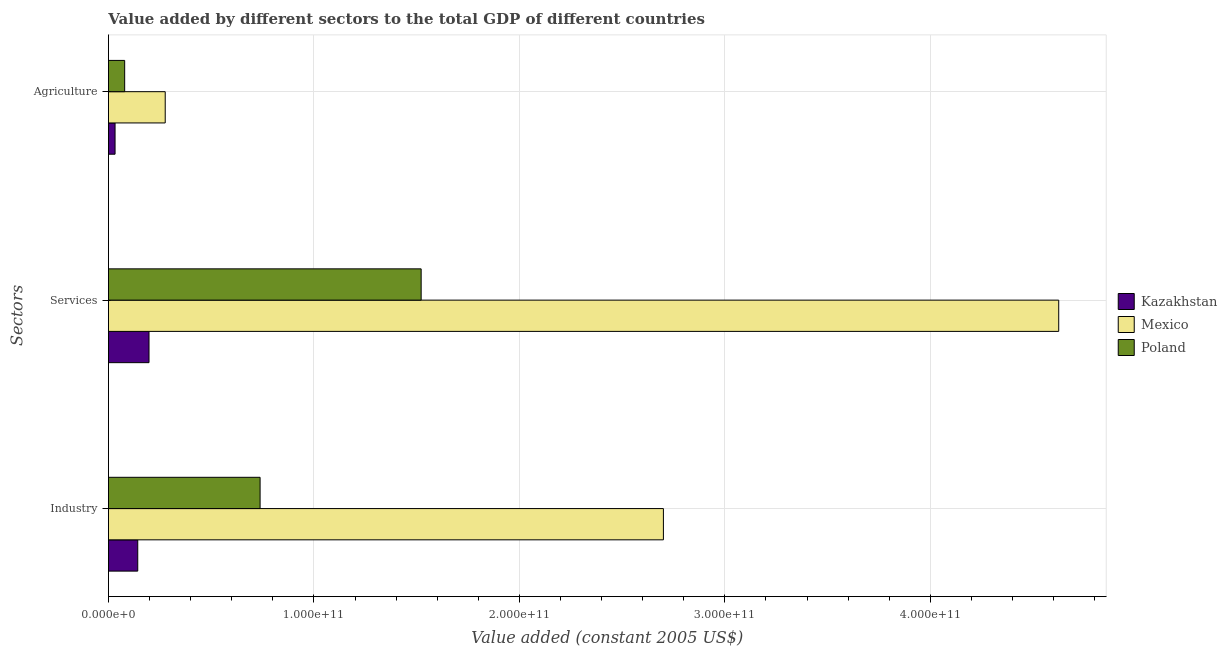How many groups of bars are there?
Offer a very short reply. 3. Are the number of bars per tick equal to the number of legend labels?
Make the answer very short. Yes. How many bars are there on the 3rd tick from the top?
Your answer should be very brief. 3. How many bars are there on the 3rd tick from the bottom?
Provide a short and direct response. 3. What is the label of the 3rd group of bars from the top?
Provide a succinct answer. Industry. What is the value added by agricultural sector in Mexico?
Offer a very short reply. 2.76e+1. Across all countries, what is the maximum value added by services?
Ensure brevity in your answer.  4.62e+11. Across all countries, what is the minimum value added by services?
Provide a succinct answer. 1.97e+1. In which country was the value added by agricultural sector minimum?
Offer a very short reply. Kazakhstan. What is the total value added by agricultural sector in the graph?
Offer a very short reply. 3.88e+1. What is the difference between the value added by services in Mexico and that in Kazakhstan?
Provide a short and direct response. 4.43e+11. What is the difference between the value added by agricultural sector in Kazakhstan and the value added by services in Mexico?
Your answer should be compact. -4.59e+11. What is the average value added by services per country?
Provide a short and direct response. 2.11e+11. What is the difference between the value added by industrial sector and value added by services in Mexico?
Provide a succinct answer. -1.92e+11. In how many countries, is the value added by industrial sector greater than 140000000000 US$?
Your answer should be compact. 1. What is the ratio of the value added by agricultural sector in Kazakhstan to that in Mexico?
Your answer should be compact. 0.12. Is the value added by industrial sector in Mexico less than that in Kazakhstan?
Offer a terse response. No. What is the difference between the highest and the second highest value added by agricultural sector?
Keep it short and to the point. 1.97e+1. What is the difference between the highest and the lowest value added by agricultural sector?
Ensure brevity in your answer.  2.44e+1. What does the 3rd bar from the top in Industry represents?
Ensure brevity in your answer.  Kazakhstan. Is it the case that in every country, the sum of the value added by industrial sector and value added by services is greater than the value added by agricultural sector?
Give a very brief answer. Yes. How many bars are there?
Give a very brief answer. 9. Are all the bars in the graph horizontal?
Make the answer very short. Yes. How many countries are there in the graph?
Your answer should be very brief. 3. What is the difference between two consecutive major ticks on the X-axis?
Provide a short and direct response. 1.00e+11. Does the graph contain any zero values?
Offer a terse response. No. Where does the legend appear in the graph?
Make the answer very short. Center right. What is the title of the graph?
Your answer should be compact. Value added by different sectors to the total GDP of different countries. Does "Vanuatu" appear as one of the legend labels in the graph?
Your answer should be very brief. No. What is the label or title of the X-axis?
Provide a succinct answer. Value added (constant 2005 US$). What is the label or title of the Y-axis?
Offer a terse response. Sectors. What is the Value added (constant 2005 US$) of Kazakhstan in Industry?
Keep it short and to the point. 1.43e+1. What is the Value added (constant 2005 US$) in Mexico in Industry?
Keep it short and to the point. 2.70e+11. What is the Value added (constant 2005 US$) of Poland in Industry?
Offer a terse response. 7.38e+1. What is the Value added (constant 2005 US$) in Kazakhstan in Services?
Provide a short and direct response. 1.97e+1. What is the Value added (constant 2005 US$) of Mexico in Services?
Provide a short and direct response. 4.62e+11. What is the Value added (constant 2005 US$) in Poland in Services?
Your answer should be compact. 1.52e+11. What is the Value added (constant 2005 US$) in Kazakhstan in Agriculture?
Offer a very short reply. 3.22e+09. What is the Value added (constant 2005 US$) in Mexico in Agriculture?
Offer a very short reply. 2.76e+1. What is the Value added (constant 2005 US$) of Poland in Agriculture?
Provide a short and direct response. 7.90e+09. Across all Sectors, what is the maximum Value added (constant 2005 US$) of Kazakhstan?
Provide a short and direct response. 1.97e+1. Across all Sectors, what is the maximum Value added (constant 2005 US$) of Mexico?
Ensure brevity in your answer.  4.62e+11. Across all Sectors, what is the maximum Value added (constant 2005 US$) in Poland?
Your answer should be compact. 1.52e+11. Across all Sectors, what is the minimum Value added (constant 2005 US$) in Kazakhstan?
Keep it short and to the point. 3.22e+09. Across all Sectors, what is the minimum Value added (constant 2005 US$) in Mexico?
Offer a very short reply. 2.76e+1. Across all Sectors, what is the minimum Value added (constant 2005 US$) of Poland?
Your response must be concise. 7.90e+09. What is the total Value added (constant 2005 US$) of Kazakhstan in the graph?
Ensure brevity in your answer.  3.72e+1. What is the total Value added (constant 2005 US$) of Mexico in the graph?
Provide a short and direct response. 7.60e+11. What is the total Value added (constant 2005 US$) in Poland in the graph?
Offer a terse response. 2.34e+11. What is the difference between the Value added (constant 2005 US$) of Kazakhstan in Industry and that in Services?
Give a very brief answer. -5.48e+09. What is the difference between the Value added (constant 2005 US$) in Mexico in Industry and that in Services?
Your answer should be very brief. -1.92e+11. What is the difference between the Value added (constant 2005 US$) of Poland in Industry and that in Services?
Keep it short and to the point. -7.84e+1. What is the difference between the Value added (constant 2005 US$) in Kazakhstan in Industry and that in Agriculture?
Offer a terse response. 1.10e+1. What is the difference between the Value added (constant 2005 US$) of Mexico in Industry and that in Agriculture?
Provide a short and direct response. 2.42e+11. What is the difference between the Value added (constant 2005 US$) of Poland in Industry and that in Agriculture?
Your answer should be very brief. 6.59e+1. What is the difference between the Value added (constant 2005 US$) of Kazakhstan in Services and that in Agriculture?
Provide a succinct answer. 1.65e+1. What is the difference between the Value added (constant 2005 US$) in Mexico in Services and that in Agriculture?
Keep it short and to the point. 4.35e+11. What is the difference between the Value added (constant 2005 US$) of Poland in Services and that in Agriculture?
Offer a terse response. 1.44e+11. What is the difference between the Value added (constant 2005 US$) in Kazakhstan in Industry and the Value added (constant 2005 US$) in Mexico in Services?
Offer a terse response. -4.48e+11. What is the difference between the Value added (constant 2005 US$) of Kazakhstan in Industry and the Value added (constant 2005 US$) of Poland in Services?
Provide a succinct answer. -1.38e+11. What is the difference between the Value added (constant 2005 US$) in Mexico in Industry and the Value added (constant 2005 US$) in Poland in Services?
Ensure brevity in your answer.  1.18e+11. What is the difference between the Value added (constant 2005 US$) of Kazakhstan in Industry and the Value added (constant 2005 US$) of Mexico in Agriculture?
Your response must be concise. -1.34e+1. What is the difference between the Value added (constant 2005 US$) in Kazakhstan in Industry and the Value added (constant 2005 US$) in Poland in Agriculture?
Provide a short and direct response. 6.37e+09. What is the difference between the Value added (constant 2005 US$) in Mexico in Industry and the Value added (constant 2005 US$) in Poland in Agriculture?
Provide a short and direct response. 2.62e+11. What is the difference between the Value added (constant 2005 US$) of Kazakhstan in Services and the Value added (constant 2005 US$) of Mexico in Agriculture?
Your answer should be compact. -7.89e+09. What is the difference between the Value added (constant 2005 US$) of Kazakhstan in Services and the Value added (constant 2005 US$) of Poland in Agriculture?
Offer a very short reply. 1.18e+1. What is the difference between the Value added (constant 2005 US$) in Mexico in Services and the Value added (constant 2005 US$) in Poland in Agriculture?
Offer a terse response. 4.55e+11. What is the average Value added (constant 2005 US$) of Kazakhstan per Sectors?
Offer a very short reply. 1.24e+1. What is the average Value added (constant 2005 US$) of Mexico per Sectors?
Keep it short and to the point. 2.53e+11. What is the average Value added (constant 2005 US$) of Poland per Sectors?
Ensure brevity in your answer.  7.80e+1. What is the difference between the Value added (constant 2005 US$) in Kazakhstan and Value added (constant 2005 US$) in Mexico in Industry?
Your response must be concise. -2.56e+11. What is the difference between the Value added (constant 2005 US$) of Kazakhstan and Value added (constant 2005 US$) of Poland in Industry?
Offer a very short reply. -5.95e+1. What is the difference between the Value added (constant 2005 US$) in Mexico and Value added (constant 2005 US$) in Poland in Industry?
Make the answer very short. 1.96e+11. What is the difference between the Value added (constant 2005 US$) of Kazakhstan and Value added (constant 2005 US$) of Mexico in Services?
Ensure brevity in your answer.  -4.43e+11. What is the difference between the Value added (constant 2005 US$) of Kazakhstan and Value added (constant 2005 US$) of Poland in Services?
Offer a very short reply. -1.32e+11. What is the difference between the Value added (constant 2005 US$) of Mexico and Value added (constant 2005 US$) of Poland in Services?
Offer a very short reply. 3.10e+11. What is the difference between the Value added (constant 2005 US$) in Kazakhstan and Value added (constant 2005 US$) in Mexico in Agriculture?
Your answer should be compact. -2.44e+1. What is the difference between the Value added (constant 2005 US$) in Kazakhstan and Value added (constant 2005 US$) in Poland in Agriculture?
Your answer should be compact. -4.68e+09. What is the difference between the Value added (constant 2005 US$) in Mexico and Value added (constant 2005 US$) in Poland in Agriculture?
Your answer should be compact. 1.97e+1. What is the ratio of the Value added (constant 2005 US$) in Kazakhstan in Industry to that in Services?
Offer a terse response. 0.72. What is the ratio of the Value added (constant 2005 US$) of Mexico in Industry to that in Services?
Your answer should be compact. 0.58. What is the ratio of the Value added (constant 2005 US$) in Poland in Industry to that in Services?
Provide a short and direct response. 0.48. What is the ratio of the Value added (constant 2005 US$) of Kazakhstan in Industry to that in Agriculture?
Give a very brief answer. 4.43. What is the ratio of the Value added (constant 2005 US$) in Mexico in Industry to that in Agriculture?
Provide a short and direct response. 9.77. What is the ratio of the Value added (constant 2005 US$) in Poland in Industry to that in Agriculture?
Make the answer very short. 9.34. What is the ratio of the Value added (constant 2005 US$) in Kazakhstan in Services to that in Agriculture?
Your answer should be compact. 6.13. What is the ratio of the Value added (constant 2005 US$) of Mexico in Services to that in Agriculture?
Give a very brief answer. 16.73. What is the ratio of the Value added (constant 2005 US$) of Poland in Services to that in Agriculture?
Keep it short and to the point. 19.26. What is the difference between the highest and the second highest Value added (constant 2005 US$) in Kazakhstan?
Make the answer very short. 5.48e+09. What is the difference between the highest and the second highest Value added (constant 2005 US$) of Mexico?
Give a very brief answer. 1.92e+11. What is the difference between the highest and the second highest Value added (constant 2005 US$) of Poland?
Your response must be concise. 7.84e+1. What is the difference between the highest and the lowest Value added (constant 2005 US$) of Kazakhstan?
Provide a short and direct response. 1.65e+1. What is the difference between the highest and the lowest Value added (constant 2005 US$) of Mexico?
Ensure brevity in your answer.  4.35e+11. What is the difference between the highest and the lowest Value added (constant 2005 US$) of Poland?
Your response must be concise. 1.44e+11. 